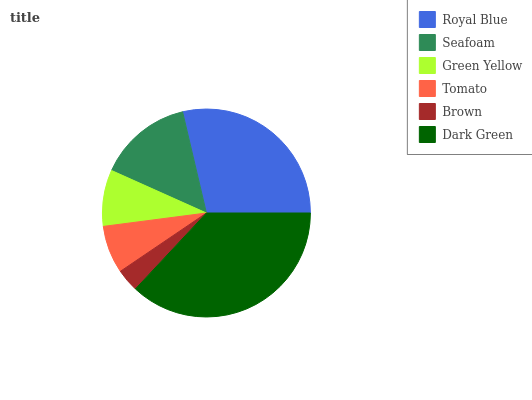Is Brown the minimum?
Answer yes or no. Yes. Is Dark Green the maximum?
Answer yes or no. Yes. Is Seafoam the minimum?
Answer yes or no. No. Is Seafoam the maximum?
Answer yes or no. No. Is Royal Blue greater than Seafoam?
Answer yes or no. Yes. Is Seafoam less than Royal Blue?
Answer yes or no. Yes. Is Seafoam greater than Royal Blue?
Answer yes or no. No. Is Royal Blue less than Seafoam?
Answer yes or no. No. Is Seafoam the high median?
Answer yes or no. Yes. Is Green Yellow the low median?
Answer yes or no. Yes. Is Tomato the high median?
Answer yes or no. No. Is Dark Green the low median?
Answer yes or no. No. 